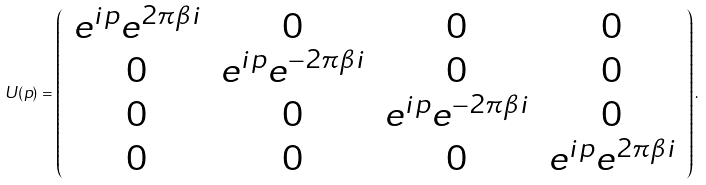<formula> <loc_0><loc_0><loc_500><loc_500>U ( p ) = \left ( \begin{array} { c c c c } e ^ { i p } e ^ { 2 \pi \beta i } & 0 & 0 & 0 \\ 0 & e ^ { i p } e ^ { - 2 \pi \beta i } & 0 & 0 \\ 0 & 0 & e ^ { i p } e ^ { - 2 \pi \beta i } & 0 \\ 0 & 0 & 0 & e ^ { i p } e ^ { 2 \pi \beta i } \\ \end{array} \right ) .</formula> 